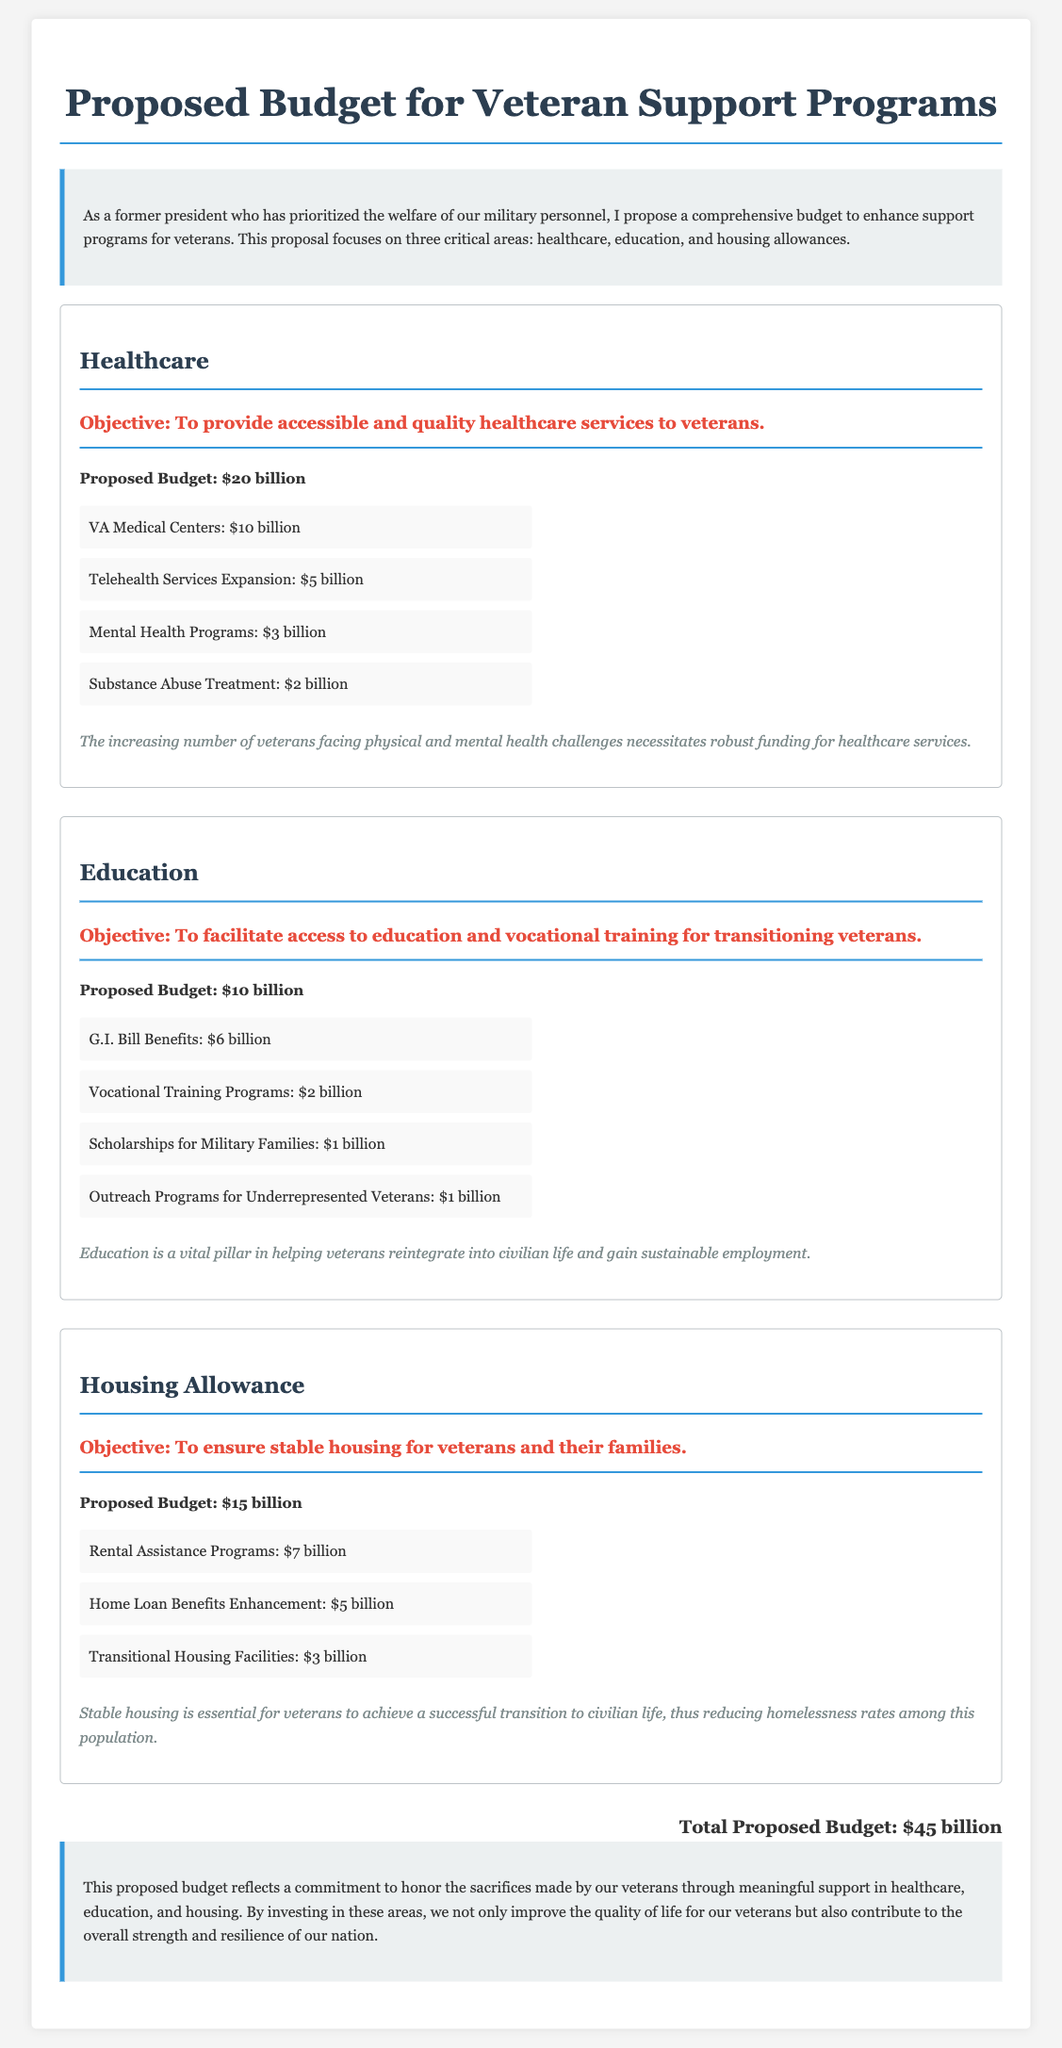What is the proposed budget for veteran healthcare? The proposed budget for veteran healthcare is explicitly stated in the document.
Answer: $20 billion What is the allocation for VA Medical Centers? The document provides specific details on the budget allocation for various healthcare services.
Answer: $10 billion How much is allocated for Telehealth Services Expansion? The outlined budget includes particular amounts dedicated to different programs, including Telehealth Services.
Answer: $5 billion What is the total proposed budget for veteran support programs? The total budget, calculated from all sections in the document, is provided clearly at the end.
Answer: $45 billion What is the budget allocation for G.I. Bill Benefits? The education section lists the specific budget for G.I. Bill Benefits, which is relevant to veteran education support.
Answer: $6 billion What is the objective of the housing allowance budget? The document specifies the objective for each budget area, highlighting the goals for housing support.
Answer: To ensure stable housing for veterans and their families What funding amount is allocated for Rental Assistance Programs? Specific amounts for each housing program are given in the budget section dedicated to housing.
Answer: $7 billion What initiatives fall under the education budget? The document outlines various programs associated with education funding for veterans, which encompasses several initiatives.
Answer: Vocational Training Programs How much is the proposed budget for scholarships for military families? The breakdown in the education section provides funds for specific scholarships that benefit military families.
Answer: $1 billion What is the goal of the mental health programs outlined? Goals for each section are summarized to highlight the support intended for veterans, particularly regarding mental health.
Answer: To provide accessible and quality healthcare services to veterans 